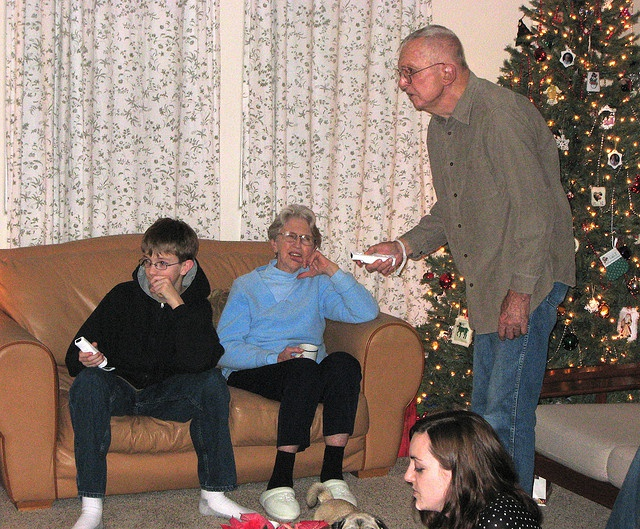Describe the objects in this image and their specific colors. I can see couch in pink, brown, and gray tones, people in pink, gray, blue, and navy tones, people in pink, black, gray, lightgray, and brown tones, people in pink, black, gray, and brown tones, and couch in pink, black, and gray tones in this image. 